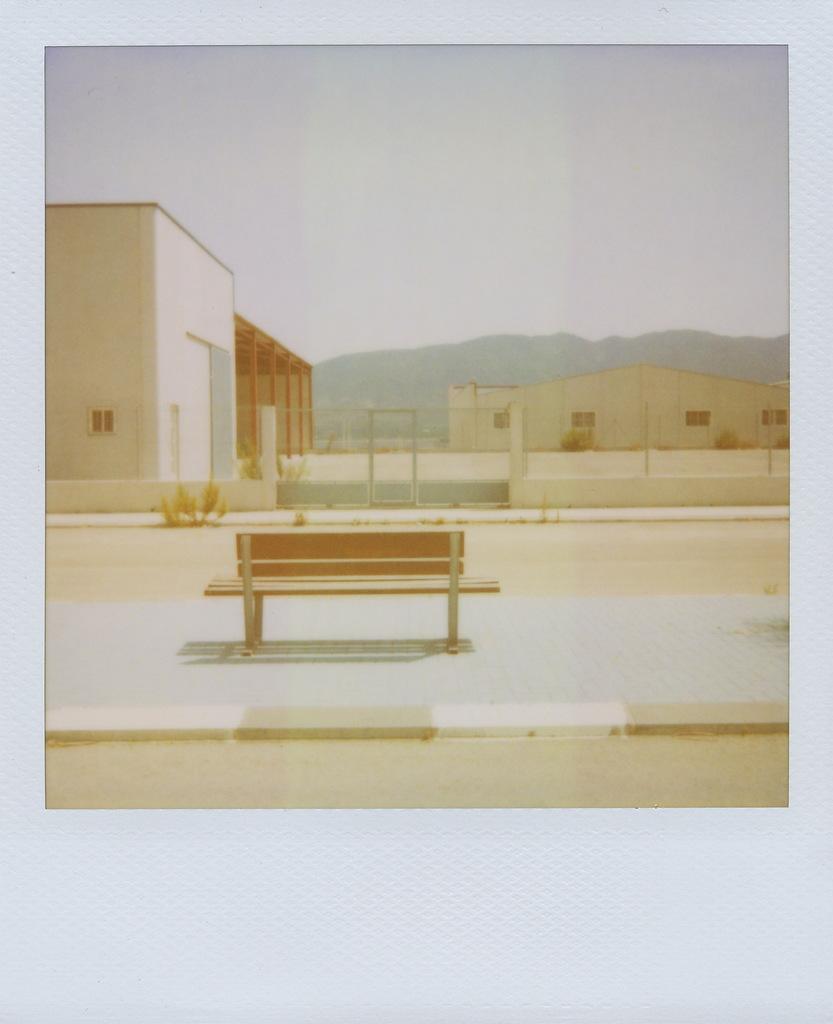How would you summarize this image in a sentence or two? In this picture I can see buildings and few plants and a bench and I can see metal fence and a hill and I can see a cloudy sky. 